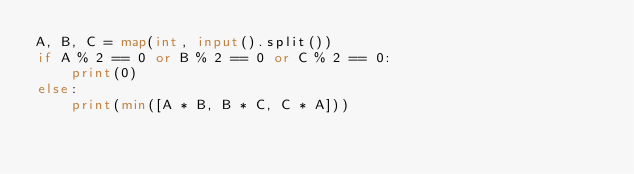<code> <loc_0><loc_0><loc_500><loc_500><_Python_>A, B, C = map(int, input().split())
if A % 2 == 0 or B % 2 == 0 or C % 2 == 0:
    print(0)
else:
    print(min([A * B, B * C, C * A]))
</code> 